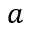<formula> <loc_0><loc_0><loc_500><loc_500>a</formula> 